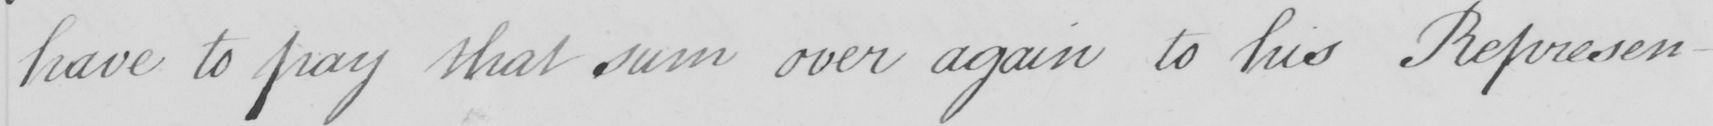What does this handwritten line say? have to pay that sum over again to his Represen- 